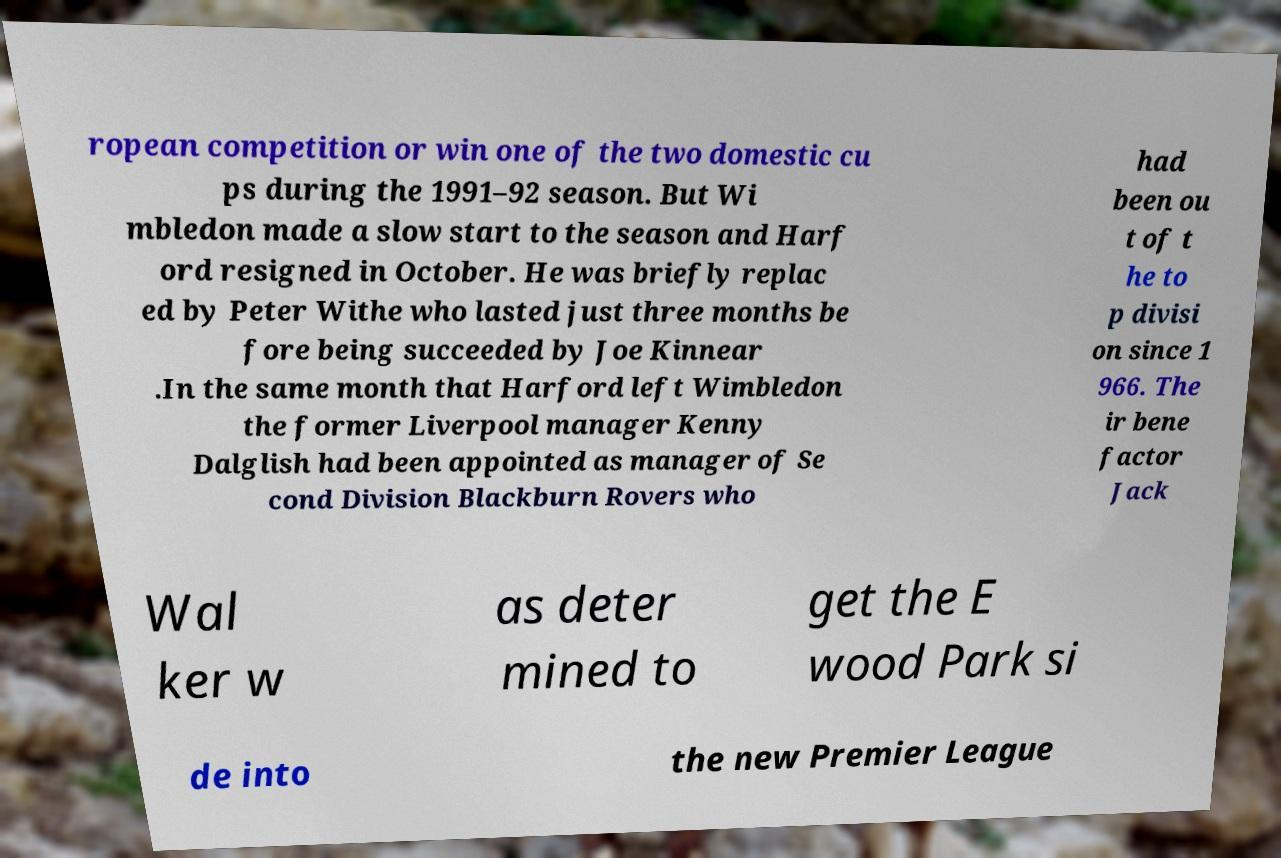What messages or text are displayed in this image? I need them in a readable, typed format. ropean competition or win one of the two domestic cu ps during the 1991–92 season. But Wi mbledon made a slow start to the season and Harf ord resigned in October. He was briefly replac ed by Peter Withe who lasted just three months be fore being succeeded by Joe Kinnear .In the same month that Harford left Wimbledon the former Liverpool manager Kenny Dalglish had been appointed as manager of Se cond Division Blackburn Rovers who had been ou t of t he to p divisi on since 1 966. The ir bene factor Jack Wal ker w as deter mined to get the E wood Park si de into the new Premier League 